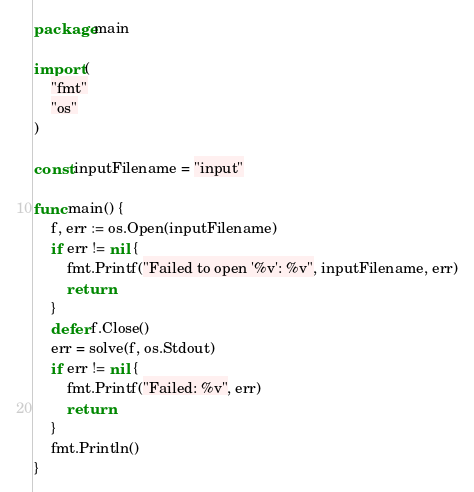Convert code to text. <code><loc_0><loc_0><loc_500><loc_500><_Go_>package main

import (
	"fmt"
	"os"
)

const inputFilename = "input"

func main() {
	f, err := os.Open(inputFilename)
	if err != nil {
		fmt.Printf("Failed to open '%v': %v", inputFilename, err)
		return
	}
	defer f.Close()
	err = solve(f, os.Stdout)
	if err != nil {
		fmt.Printf("Failed: %v", err)
		return
	}
	fmt.Println()
}
</code> 